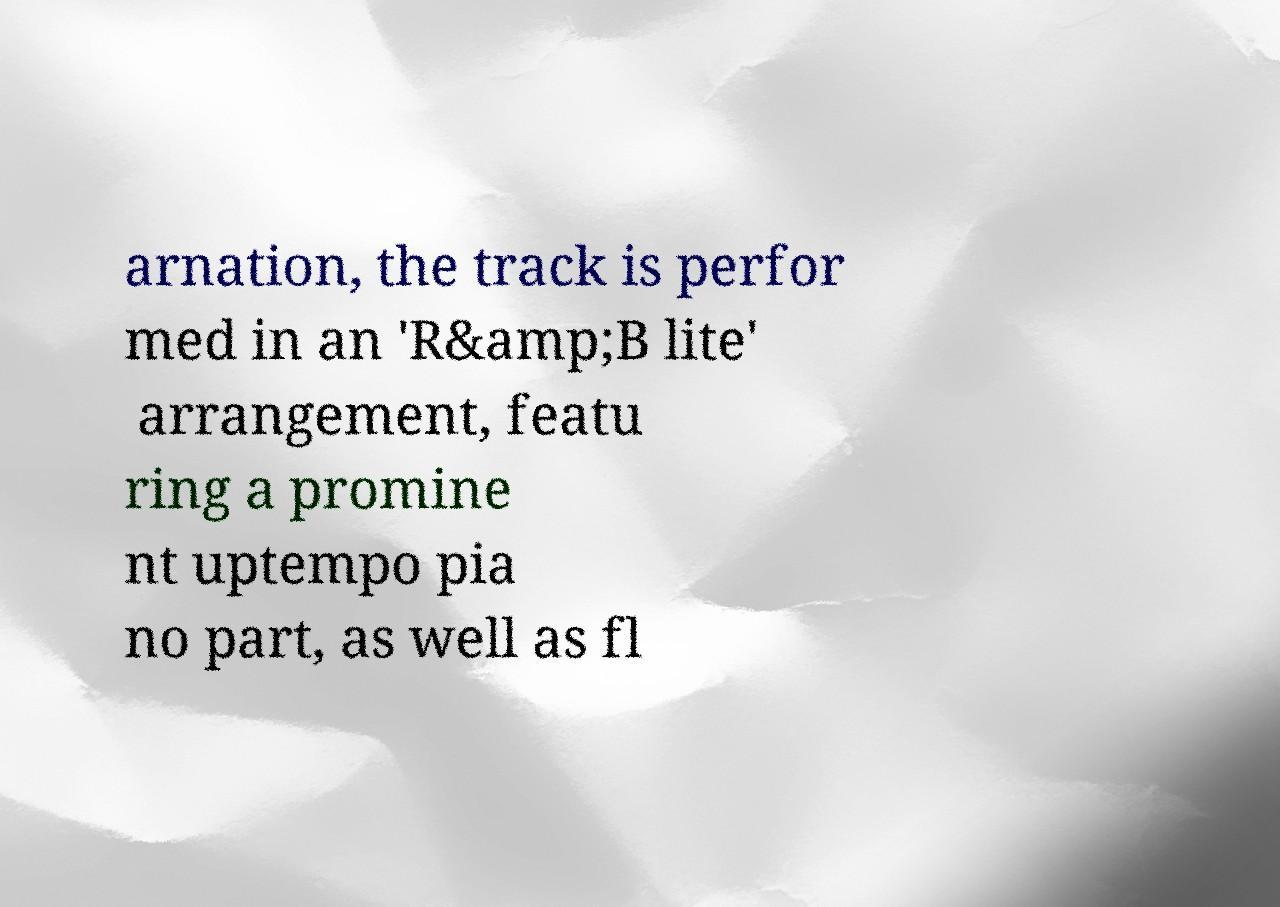Please identify and transcribe the text found in this image. arnation, the track is perfor med in an 'R&amp;B lite' arrangement, featu ring a promine nt uptempo pia no part, as well as fl 